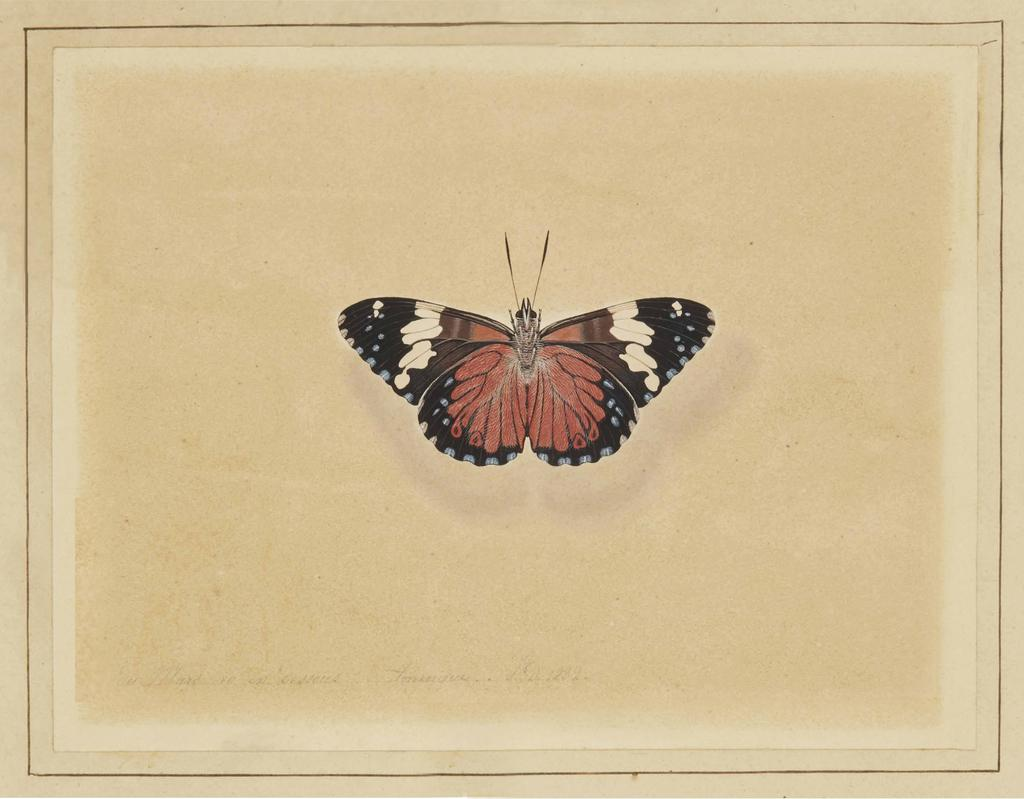What is depicted in the drawing in the image? There is a drawing of a butterfly in the image. What else can be seen in the image besides the drawing? There are borders in the image. What type of note is being passed between the butterflies in the image? There are no butterflies or notes present in the image; it only contains a drawing of a butterfly and borders. 